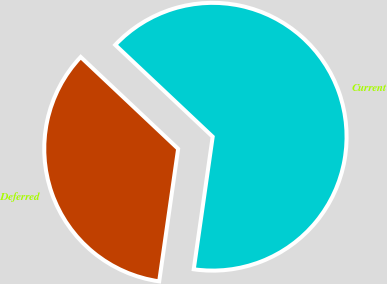Convert chart. <chart><loc_0><loc_0><loc_500><loc_500><pie_chart><fcel>Current<fcel>Deferred<nl><fcel>65.23%<fcel>34.77%<nl></chart> 